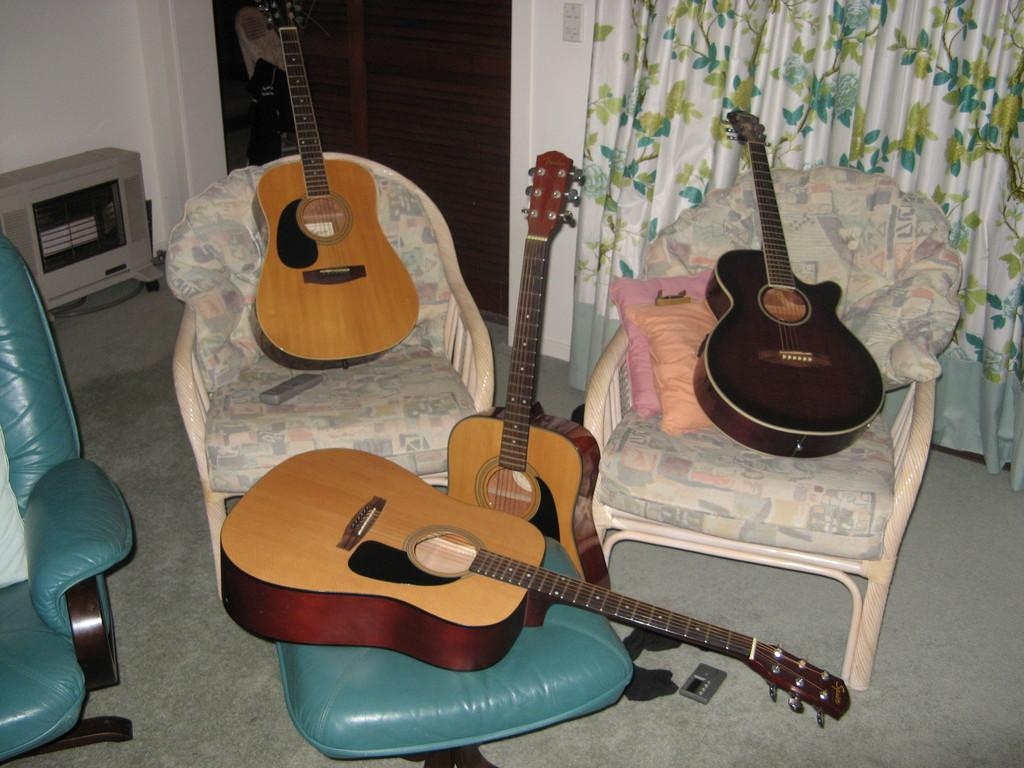What type of furniture is present in the image? There are chairs in the image. What can be seen in the background of the image? There is a curtain in the back side of the image. What are the chairs holding? Guitars are placed on the chairs. What color are the chairs, curtain, and guitars in the image? All the mentioned objects are in brown color. What type of question is being asked in the image? There is no question being asked in the image; it features chairs, a curtain, and guitars. Are the guitars wearing stockings in the image? There are no stockings present in the image, and guitars do not wear stockings. 